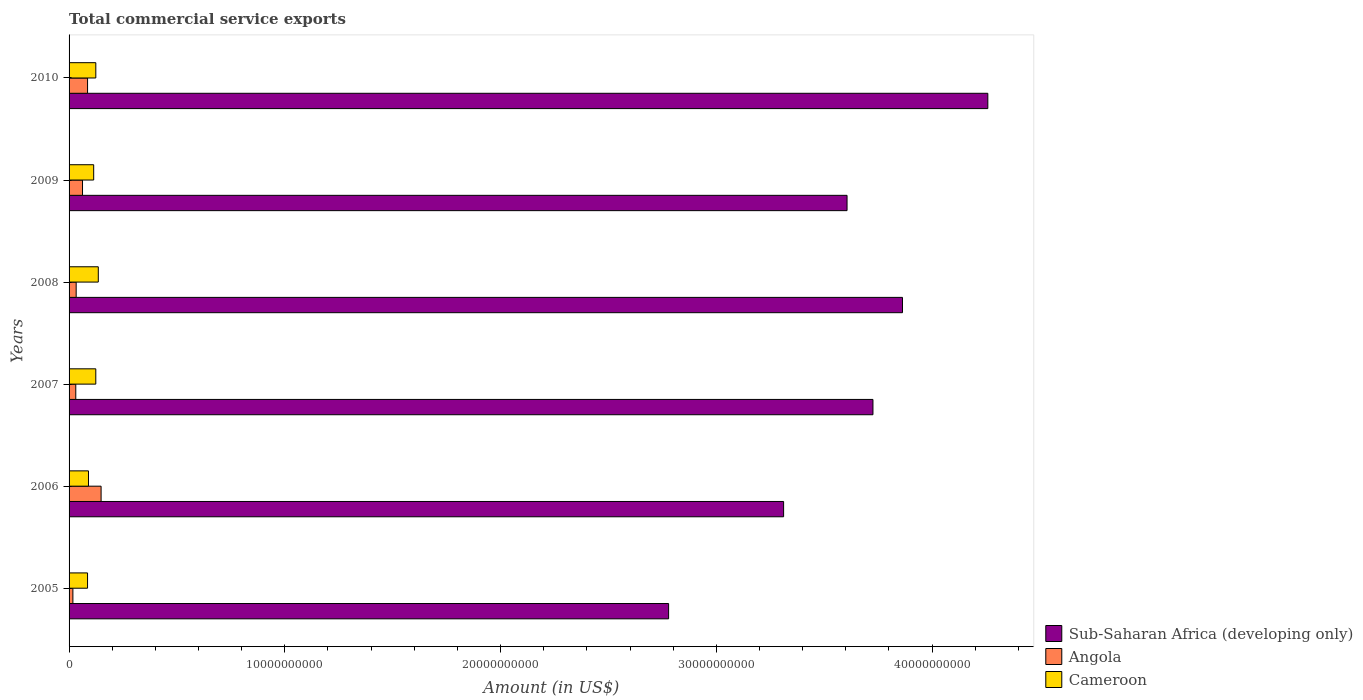Are the number of bars on each tick of the Y-axis equal?
Make the answer very short. Yes. How many bars are there on the 5th tick from the top?
Offer a terse response. 3. In how many cases, is the number of bars for a given year not equal to the number of legend labels?
Give a very brief answer. 0. What is the total commercial service exports in Sub-Saharan Africa (developing only) in 2009?
Your answer should be very brief. 3.61e+1. Across all years, what is the maximum total commercial service exports in Cameroon?
Keep it short and to the point. 1.35e+09. Across all years, what is the minimum total commercial service exports in Sub-Saharan Africa (developing only)?
Keep it short and to the point. 2.78e+1. In which year was the total commercial service exports in Sub-Saharan Africa (developing only) minimum?
Provide a succinct answer. 2005. What is the total total commercial service exports in Sub-Saharan Africa (developing only) in the graph?
Keep it short and to the point. 2.15e+11. What is the difference between the total commercial service exports in Cameroon in 2005 and that in 2008?
Ensure brevity in your answer.  -4.98e+08. What is the difference between the total commercial service exports in Angola in 2005 and the total commercial service exports in Sub-Saharan Africa (developing only) in 2009?
Offer a very short reply. -3.59e+1. What is the average total commercial service exports in Cameroon per year?
Make the answer very short. 1.12e+09. In the year 2009, what is the difference between the total commercial service exports in Angola and total commercial service exports in Cameroon?
Make the answer very short. -5.18e+08. In how many years, is the total commercial service exports in Angola greater than 32000000000 US$?
Provide a short and direct response. 0. What is the ratio of the total commercial service exports in Cameroon in 2006 to that in 2008?
Provide a succinct answer. 0.66. Is the total commercial service exports in Angola in 2006 less than that in 2010?
Make the answer very short. No. Is the difference between the total commercial service exports in Angola in 2008 and 2010 greater than the difference between the total commercial service exports in Cameroon in 2008 and 2010?
Provide a short and direct response. No. What is the difference between the highest and the second highest total commercial service exports in Angola?
Give a very brief answer. 6.27e+08. What is the difference between the highest and the lowest total commercial service exports in Angola?
Offer a very short reply. 1.31e+09. In how many years, is the total commercial service exports in Angola greater than the average total commercial service exports in Angola taken over all years?
Keep it short and to the point. 2. What does the 1st bar from the top in 2008 represents?
Provide a succinct answer. Cameroon. What does the 3rd bar from the bottom in 2009 represents?
Offer a very short reply. Cameroon. How many bars are there?
Give a very brief answer. 18. Are all the bars in the graph horizontal?
Offer a terse response. Yes. Are the values on the major ticks of X-axis written in scientific E-notation?
Provide a succinct answer. No. How many legend labels are there?
Offer a very short reply. 3. What is the title of the graph?
Provide a short and direct response. Total commercial service exports. Does "Greece" appear as one of the legend labels in the graph?
Ensure brevity in your answer.  No. What is the label or title of the X-axis?
Provide a succinct answer. Amount (in US$). What is the Amount (in US$) in Sub-Saharan Africa (developing only) in 2005?
Your answer should be very brief. 2.78e+1. What is the Amount (in US$) of Angola in 2005?
Make the answer very short. 1.77e+08. What is the Amount (in US$) in Cameroon in 2005?
Your answer should be compact. 8.57e+08. What is the Amount (in US$) of Sub-Saharan Africa (developing only) in 2006?
Offer a very short reply. 3.31e+1. What is the Amount (in US$) in Angola in 2006?
Ensure brevity in your answer.  1.48e+09. What is the Amount (in US$) in Cameroon in 2006?
Keep it short and to the point. 9.00e+08. What is the Amount (in US$) in Sub-Saharan Africa (developing only) in 2007?
Offer a terse response. 3.73e+1. What is the Amount (in US$) in Angola in 2007?
Provide a short and direct response. 3.11e+08. What is the Amount (in US$) in Cameroon in 2007?
Your answer should be very brief. 1.24e+09. What is the Amount (in US$) of Sub-Saharan Africa (developing only) in 2008?
Your answer should be compact. 3.86e+1. What is the Amount (in US$) of Angola in 2008?
Make the answer very short. 3.29e+08. What is the Amount (in US$) of Cameroon in 2008?
Your answer should be very brief. 1.35e+09. What is the Amount (in US$) in Sub-Saharan Africa (developing only) in 2009?
Give a very brief answer. 3.61e+1. What is the Amount (in US$) of Angola in 2009?
Make the answer very short. 6.23e+08. What is the Amount (in US$) of Cameroon in 2009?
Keep it short and to the point. 1.14e+09. What is the Amount (in US$) of Sub-Saharan Africa (developing only) in 2010?
Give a very brief answer. 4.26e+1. What is the Amount (in US$) in Angola in 2010?
Provide a short and direct response. 8.57e+08. What is the Amount (in US$) in Cameroon in 2010?
Ensure brevity in your answer.  1.24e+09. Across all years, what is the maximum Amount (in US$) of Sub-Saharan Africa (developing only)?
Your answer should be compact. 4.26e+1. Across all years, what is the maximum Amount (in US$) of Angola?
Your answer should be compact. 1.48e+09. Across all years, what is the maximum Amount (in US$) of Cameroon?
Ensure brevity in your answer.  1.35e+09. Across all years, what is the minimum Amount (in US$) in Sub-Saharan Africa (developing only)?
Make the answer very short. 2.78e+1. Across all years, what is the minimum Amount (in US$) of Angola?
Your answer should be compact. 1.77e+08. Across all years, what is the minimum Amount (in US$) in Cameroon?
Provide a succinct answer. 8.57e+08. What is the total Amount (in US$) of Sub-Saharan Africa (developing only) in the graph?
Your answer should be very brief. 2.15e+11. What is the total Amount (in US$) in Angola in the graph?
Ensure brevity in your answer.  3.78e+09. What is the total Amount (in US$) in Cameroon in the graph?
Provide a succinct answer. 6.73e+09. What is the difference between the Amount (in US$) in Sub-Saharan Africa (developing only) in 2005 and that in 2006?
Provide a short and direct response. -5.33e+09. What is the difference between the Amount (in US$) in Angola in 2005 and that in 2006?
Make the answer very short. -1.31e+09. What is the difference between the Amount (in US$) in Cameroon in 2005 and that in 2006?
Your response must be concise. -4.33e+07. What is the difference between the Amount (in US$) of Sub-Saharan Africa (developing only) in 2005 and that in 2007?
Give a very brief answer. -9.47e+09. What is the difference between the Amount (in US$) of Angola in 2005 and that in 2007?
Make the answer very short. -1.34e+08. What is the difference between the Amount (in US$) in Cameroon in 2005 and that in 2007?
Offer a terse response. -3.82e+08. What is the difference between the Amount (in US$) of Sub-Saharan Africa (developing only) in 2005 and that in 2008?
Your response must be concise. -1.08e+1. What is the difference between the Amount (in US$) in Angola in 2005 and that in 2008?
Your answer should be compact. -1.53e+08. What is the difference between the Amount (in US$) in Cameroon in 2005 and that in 2008?
Your response must be concise. -4.98e+08. What is the difference between the Amount (in US$) of Sub-Saharan Africa (developing only) in 2005 and that in 2009?
Your answer should be compact. -8.27e+09. What is the difference between the Amount (in US$) in Angola in 2005 and that in 2009?
Provide a succinct answer. -4.46e+08. What is the difference between the Amount (in US$) in Cameroon in 2005 and that in 2009?
Offer a terse response. -2.85e+08. What is the difference between the Amount (in US$) in Sub-Saharan Africa (developing only) in 2005 and that in 2010?
Your answer should be compact. -1.48e+1. What is the difference between the Amount (in US$) of Angola in 2005 and that in 2010?
Make the answer very short. -6.80e+08. What is the difference between the Amount (in US$) in Cameroon in 2005 and that in 2010?
Give a very brief answer. -3.83e+08. What is the difference between the Amount (in US$) in Sub-Saharan Africa (developing only) in 2006 and that in 2007?
Make the answer very short. -4.14e+09. What is the difference between the Amount (in US$) of Angola in 2006 and that in 2007?
Keep it short and to the point. 1.17e+09. What is the difference between the Amount (in US$) of Cameroon in 2006 and that in 2007?
Provide a short and direct response. -3.39e+08. What is the difference between the Amount (in US$) of Sub-Saharan Africa (developing only) in 2006 and that in 2008?
Your answer should be very brief. -5.51e+09. What is the difference between the Amount (in US$) of Angola in 2006 and that in 2008?
Give a very brief answer. 1.15e+09. What is the difference between the Amount (in US$) in Cameroon in 2006 and that in 2008?
Offer a terse response. -4.55e+08. What is the difference between the Amount (in US$) in Sub-Saharan Africa (developing only) in 2006 and that in 2009?
Your answer should be compact. -2.94e+09. What is the difference between the Amount (in US$) of Angola in 2006 and that in 2009?
Ensure brevity in your answer.  8.61e+08. What is the difference between the Amount (in US$) of Cameroon in 2006 and that in 2009?
Ensure brevity in your answer.  -2.41e+08. What is the difference between the Amount (in US$) of Sub-Saharan Africa (developing only) in 2006 and that in 2010?
Your answer should be very brief. -9.47e+09. What is the difference between the Amount (in US$) in Angola in 2006 and that in 2010?
Your response must be concise. 6.27e+08. What is the difference between the Amount (in US$) in Cameroon in 2006 and that in 2010?
Your answer should be compact. -3.40e+08. What is the difference between the Amount (in US$) in Sub-Saharan Africa (developing only) in 2007 and that in 2008?
Your response must be concise. -1.37e+09. What is the difference between the Amount (in US$) of Angola in 2007 and that in 2008?
Your answer should be very brief. -1.87e+07. What is the difference between the Amount (in US$) in Cameroon in 2007 and that in 2008?
Ensure brevity in your answer.  -1.16e+08. What is the difference between the Amount (in US$) in Sub-Saharan Africa (developing only) in 2007 and that in 2009?
Give a very brief answer. 1.20e+09. What is the difference between the Amount (in US$) in Angola in 2007 and that in 2009?
Ensure brevity in your answer.  -3.12e+08. What is the difference between the Amount (in US$) of Cameroon in 2007 and that in 2009?
Ensure brevity in your answer.  9.78e+07. What is the difference between the Amount (in US$) in Sub-Saharan Africa (developing only) in 2007 and that in 2010?
Provide a short and direct response. -5.32e+09. What is the difference between the Amount (in US$) in Angola in 2007 and that in 2010?
Keep it short and to the point. -5.46e+08. What is the difference between the Amount (in US$) in Cameroon in 2007 and that in 2010?
Ensure brevity in your answer.  -8.30e+05. What is the difference between the Amount (in US$) in Sub-Saharan Africa (developing only) in 2008 and that in 2009?
Your response must be concise. 2.57e+09. What is the difference between the Amount (in US$) of Angola in 2008 and that in 2009?
Your answer should be very brief. -2.94e+08. What is the difference between the Amount (in US$) of Cameroon in 2008 and that in 2009?
Give a very brief answer. 2.13e+08. What is the difference between the Amount (in US$) of Sub-Saharan Africa (developing only) in 2008 and that in 2010?
Make the answer very short. -3.96e+09. What is the difference between the Amount (in US$) of Angola in 2008 and that in 2010?
Keep it short and to the point. -5.27e+08. What is the difference between the Amount (in US$) of Cameroon in 2008 and that in 2010?
Offer a terse response. 1.15e+08. What is the difference between the Amount (in US$) in Sub-Saharan Africa (developing only) in 2009 and that in 2010?
Give a very brief answer. -6.53e+09. What is the difference between the Amount (in US$) in Angola in 2009 and that in 2010?
Make the answer very short. -2.34e+08. What is the difference between the Amount (in US$) of Cameroon in 2009 and that in 2010?
Your answer should be very brief. -9.86e+07. What is the difference between the Amount (in US$) of Sub-Saharan Africa (developing only) in 2005 and the Amount (in US$) of Angola in 2006?
Offer a terse response. 2.63e+1. What is the difference between the Amount (in US$) of Sub-Saharan Africa (developing only) in 2005 and the Amount (in US$) of Cameroon in 2006?
Make the answer very short. 2.69e+1. What is the difference between the Amount (in US$) of Angola in 2005 and the Amount (in US$) of Cameroon in 2006?
Give a very brief answer. -7.23e+08. What is the difference between the Amount (in US$) of Sub-Saharan Africa (developing only) in 2005 and the Amount (in US$) of Angola in 2007?
Keep it short and to the point. 2.75e+1. What is the difference between the Amount (in US$) in Sub-Saharan Africa (developing only) in 2005 and the Amount (in US$) in Cameroon in 2007?
Offer a terse response. 2.66e+1. What is the difference between the Amount (in US$) of Angola in 2005 and the Amount (in US$) of Cameroon in 2007?
Provide a short and direct response. -1.06e+09. What is the difference between the Amount (in US$) in Sub-Saharan Africa (developing only) in 2005 and the Amount (in US$) in Angola in 2008?
Your answer should be compact. 2.75e+1. What is the difference between the Amount (in US$) in Sub-Saharan Africa (developing only) in 2005 and the Amount (in US$) in Cameroon in 2008?
Make the answer very short. 2.64e+1. What is the difference between the Amount (in US$) in Angola in 2005 and the Amount (in US$) in Cameroon in 2008?
Provide a succinct answer. -1.18e+09. What is the difference between the Amount (in US$) of Sub-Saharan Africa (developing only) in 2005 and the Amount (in US$) of Angola in 2009?
Provide a succinct answer. 2.72e+1. What is the difference between the Amount (in US$) in Sub-Saharan Africa (developing only) in 2005 and the Amount (in US$) in Cameroon in 2009?
Offer a very short reply. 2.66e+1. What is the difference between the Amount (in US$) of Angola in 2005 and the Amount (in US$) of Cameroon in 2009?
Offer a terse response. -9.64e+08. What is the difference between the Amount (in US$) in Sub-Saharan Africa (developing only) in 2005 and the Amount (in US$) in Angola in 2010?
Make the answer very short. 2.69e+1. What is the difference between the Amount (in US$) of Sub-Saharan Africa (developing only) in 2005 and the Amount (in US$) of Cameroon in 2010?
Your response must be concise. 2.65e+1. What is the difference between the Amount (in US$) of Angola in 2005 and the Amount (in US$) of Cameroon in 2010?
Keep it short and to the point. -1.06e+09. What is the difference between the Amount (in US$) in Sub-Saharan Africa (developing only) in 2006 and the Amount (in US$) in Angola in 2007?
Your answer should be very brief. 3.28e+1. What is the difference between the Amount (in US$) in Sub-Saharan Africa (developing only) in 2006 and the Amount (in US$) in Cameroon in 2007?
Offer a terse response. 3.19e+1. What is the difference between the Amount (in US$) of Angola in 2006 and the Amount (in US$) of Cameroon in 2007?
Offer a terse response. 2.45e+08. What is the difference between the Amount (in US$) of Sub-Saharan Africa (developing only) in 2006 and the Amount (in US$) of Angola in 2008?
Offer a terse response. 3.28e+1. What is the difference between the Amount (in US$) in Sub-Saharan Africa (developing only) in 2006 and the Amount (in US$) in Cameroon in 2008?
Give a very brief answer. 3.18e+1. What is the difference between the Amount (in US$) in Angola in 2006 and the Amount (in US$) in Cameroon in 2008?
Your answer should be compact. 1.30e+08. What is the difference between the Amount (in US$) of Sub-Saharan Africa (developing only) in 2006 and the Amount (in US$) of Angola in 2009?
Keep it short and to the point. 3.25e+1. What is the difference between the Amount (in US$) in Sub-Saharan Africa (developing only) in 2006 and the Amount (in US$) in Cameroon in 2009?
Your answer should be compact. 3.20e+1. What is the difference between the Amount (in US$) of Angola in 2006 and the Amount (in US$) of Cameroon in 2009?
Your answer should be compact. 3.43e+08. What is the difference between the Amount (in US$) of Sub-Saharan Africa (developing only) in 2006 and the Amount (in US$) of Angola in 2010?
Your answer should be compact. 3.23e+1. What is the difference between the Amount (in US$) in Sub-Saharan Africa (developing only) in 2006 and the Amount (in US$) in Cameroon in 2010?
Your answer should be very brief. 3.19e+1. What is the difference between the Amount (in US$) of Angola in 2006 and the Amount (in US$) of Cameroon in 2010?
Your answer should be compact. 2.44e+08. What is the difference between the Amount (in US$) in Sub-Saharan Africa (developing only) in 2007 and the Amount (in US$) in Angola in 2008?
Provide a succinct answer. 3.69e+1. What is the difference between the Amount (in US$) of Sub-Saharan Africa (developing only) in 2007 and the Amount (in US$) of Cameroon in 2008?
Offer a very short reply. 3.59e+1. What is the difference between the Amount (in US$) of Angola in 2007 and the Amount (in US$) of Cameroon in 2008?
Your answer should be very brief. -1.04e+09. What is the difference between the Amount (in US$) of Sub-Saharan Africa (developing only) in 2007 and the Amount (in US$) of Angola in 2009?
Offer a terse response. 3.66e+1. What is the difference between the Amount (in US$) of Sub-Saharan Africa (developing only) in 2007 and the Amount (in US$) of Cameroon in 2009?
Give a very brief answer. 3.61e+1. What is the difference between the Amount (in US$) of Angola in 2007 and the Amount (in US$) of Cameroon in 2009?
Provide a short and direct response. -8.31e+08. What is the difference between the Amount (in US$) of Sub-Saharan Africa (developing only) in 2007 and the Amount (in US$) of Angola in 2010?
Make the answer very short. 3.64e+1. What is the difference between the Amount (in US$) in Sub-Saharan Africa (developing only) in 2007 and the Amount (in US$) in Cameroon in 2010?
Provide a short and direct response. 3.60e+1. What is the difference between the Amount (in US$) in Angola in 2007 and the Amount (in US$) in Cameroon in 2010?
Your response must be concise. -9.29e+08. What is the difference between the Amount (in US$) in Sub-Saharan Africa (developing only) in 2008 and the Amount (in US$) in Angola in 2009?
Provide a succinct answer. 3.80e+1. What is the difference between the Amount (in US$) in Sub-Saharan Africa (developing only) in 2008 and the Amount (in US$) in Cameroon in 2009?
Provide a short and direct response. 3.75e+1. What is the difference between the Amount (in US$) in Angola in 2008 and the Amount (in US$) in Cameroon in 2009?
Your answer should be compact. -8.12e+08. What is the difference between the Amount (in US$) of Sub-Saharan Africa (developing only) in 2008 and the Amount (in US$) of Angola in 2010?
Your response must be concise. 3.78e+1. What is the difference between the Amount (in US$) in Sub-Saharan Africa (developing only) in 2008 and the Amount (in US$) in Cameroon in 2010?
Ensure brevity in your answer.  3.74e+1. What is the difference between the Amount (in US$) in Angola in 2008 and the Amount (in US$) in Cameroon in 2010?
Provide a succinct answer. -9.10e+08. What is the difference between the Amount (in US$) in Sub-Saharan Africa (developing only) in 2009 and the Amount (in US$) in Angola in 2010?
Your response must be concise. 3.52e+1. What is the difference between the Amount (in US$) of Sub-Saharan Africa (developing only) in 2009 and the Amount (in US$) of Cameroon in 2010?
Your answer should be very brief. 3.48e+1. What is the difference between the Amount (in US$) of Angola in 2009 and the Amount (in US$) of Cameroon in 2010?
Your answer should be compact. -6.17e+08. What is the average Amount (in US$) in Sub-Saharan Africa (developing only) per year?
Your response must be concise. 3.59e+1. What is the average Amount (in US$) of Angola per year?
Provide a short and direct response. 6.30e+08. What is the average Amount (in US$) in Cameroon per year?
Offer a terse response. 1.12e+09. In the year 2005, what is the difference between the Amount (in US$) of Sub-Saharan Africa (developing only) and Amount (in US$) of Angola?
Your answer should be very brief. 2.76e+1. In the year 2005, what is the difference between the Amount (in US$) in Sub-Saharan Africa (developing only) and Amount (in US$) in Cameroon?
Give a very brief answer. 2.69e+1. In the year 2005, what is the difference between the Amount (in US$) in Angola and Amount (in US$) in Cameroon?
Your answer should be compact. -6.80e+08. In the year 2006, what is the difference between the Amount (in US$) in Sub-Saharan Africa (developing only) and Amount (in US$) in Angola?
Offer a very short reply. 3.16e+1. In the year 2006, what is the difference between the Amount (in US$) of Sub-Saharan Africa (developing only) and Amount (in US$) of Cameroon?
Give a very brief answer. 3.22e+1. In the year 2006, what is the difference between the Amount (in US$) of Angola and Amount (in US$) of Cameroon?
Provide a succinct answer. 5.84e+08. In the year 2007, what is the difference between the Amount (in US$) of Sub-Saharan Africa (developing only) and Amount (in US$) of Angola?
Give a very brief answer. 3.70e+1. In the year 2007, what is the difference between the Amount (in US$) in Sub-Saharan Africa (developing only) and Amount (in US$) in Cameroon?
Keep it short and to the point. 3.60e+1. In the year 2007, what is the difference between the Amount (in US$) of Angola and Amount (in US$) of Cameroon?
Your answer should be very brief. -9.28e+08. In the year 2008, what is the difference between the Amount (in US$) in Sub-Saharan Africa (developing only) and Amount (in US$) in Angola?
Give a very brief answer. 3.83e+1. In the year 2008, what is the difference between the Amount (in US$) in Sub-Saharan Africa (developing only) and Amount (in US$) in Cameroon?
Ensure brevity in your answer.  3.73e+1. In the year 2008, what is the difference between the Amount (in US$) of Angola and Amount (in US$) of Cameroon?
Make the answer very short. -1.03e+09. In the year 2009, what is the difference between the Amount (in US$) in Sub-Saharan Africa (developing only) and Amount (in US$) in Angola?
Offer a terse response. 3.54e+1. In the year 2009, what is the difference between the Amount (in US$) of Sub-Saharan Africa (developing only) and Amount (in US$) of Cameroon?
Ensure brevity in your answer.  3.49e+1. In the year 2009, what is the difference between the Amount (in US$) of Angola and Amount (in US$) of Cameroon?
Your response must be concise. -5.18e+08. In the year 2010, what is the difference between the Amount (in US$) of Sub-Saharan Africa (developing only) and Amount (in US$) of Angola?
Make the answer very short. 4.17e+1. In the year 2010, what is the difference between the Amount (in US$) of Sub-Saharan Africa (developing only) and Amount (in US$) of Cameroon?
Keep it short and to the point. 4.13e+1. In the year 2010, what is the difference between the Amount (in US$) in Angola and Amount (in US$) in Cameroon?
Keep it short and to the point. -3.83e+08. What is the ratio of the Amount (in US$) of Sub-Saharan Africa (developing only) in 2005 to that in 2006?
Your answer should be compact. 0.84. What is the ratio of the Amount (in US$) in Angola in 2005 to that in 2006?
Your answer should be compact. 0.12. What is the ratio of the Amount (in US$) of Cameroon in 2005 to that in 2006?
Ensure brevity in your answer.  0.95. What is the ratio of the Amount (in US$) in Sub-Saharan Africa (developing only) in 2005 to that in 2007?
Provide a short and direct response. 0.75. What is the ratio of the Amount (in US$) in Angola in 2005 to that in 2007?
Keep it short and to the point. 0.57. What is the ratio of the Amount (in US$) of Cameroon in 2005 to that in 2007?
Give a very brief answer. 0.69. What is the ratio of the Amount (in US$) in Sub-Saharan Africa (developing only) in 2005 to that in 2008?
Keep it short and to the point. 0.72. What is the ratio of the Amount (in US$) in Angola in 2005 to that in 2008?
Your answer should be compact. 0.54. What is the ratio of the Amount (in US$) of Cameroon in 2005 to that in 2008?
Offer a terse response. 0.63. What is the ratio of the Amount (in US$) of Sub-Saharan Africa (developing only) in 2005 to that in 2009?
Ensure brevity in your answer.  0.77. What is the ratio of the Amount (in US$) in Angola in 2005 to that in 2009?
Your response must be concise. 0.28. What is the ratio of the Amount (in US$) in Cameroon in 2005 to that in 2009?
Your answer should be compact. 0.75. What is the ratio of the Amount (in US$) of Sub-Saharan Africa (developing only) in 2005 to that in 2010?
Offer a terse response. 0.65. What is the ratio of the Amount (in US$) in Angola in 2005 to that in 2010?
Provide a succinct answer. 0.21. What is the ratio of the Amount (in US$) in Cameroon in 2005 to that in 2010?
Your answer should be compact. 0.69. What is the ratio of the Amount (in US$) in Sub-Saharan Africa (developing only) in 2006 to that in 2007?
Give a very brief answer. 0.89. What is the ratio of the Amount (in US$) of Angola in 2006 to that in 2007?
Offer a very short reply. 4.78. What is the ratio of the Amount (in US$) in Cameroon in 2006 to that in 2007?
Provide a succinct answer. 0.73. What is the ratio of the Amount (in US$) of Sub-Saharan Africa (developing only) in 2006 to that in 2008?
Your answer should be very brief. 0.86. What is the ratio of the Amount (in US$) of Angola in 2006 to that in 2008?
Offer a very short reply. 4.51. What is the ratio of the Amount (in US$) of Cameroon in 2006 to that in 2008?
Your answer should be very brief. 0.66. What is the ratio of the Amount (in US$) in Sub-Saharan Africa (developing only) in 2006 to that in 2009?
Your answer should be compact. 0.92. What is the ratio of the Amount (in US$) in Angola in 2006 to that in 2009?
Make the answer very short. 2.38. What is the ratio of the Amount (in US$) of Cameroon in 2006 to that in 2009?
Provide a succinct answer. 0.79. What is the ratio of the Amount (in US$) in Sub-Saharan Africa (developing only) in 2006 to that in 2010?
Provide a short and direct response. 0.78. What is the ratio of the Amount (in US$) in Angola in 2006 to that in 2010?
Your response must be concise. 1.73. What is the ratio of the Amount (in US$) in Cameroon in 2006 to that in 2010?
Your answer should be very brief. 0.73. What is the ratio of the Amount (in US$) of Sub-Saharan Africa (developing only) in 2007 to that in 2008?
Ensure brevity in your answer.  0.96. What is the ratio of the Amount (in US$) of Angola in 2007 to that in 2008?
Provide a succinct answer. 0.94. What is the ratio of the Amount (in US$) in Cameroon in 2007 to that in 2008?
Provide a short and direct response. 0.91. What is the ratio of the Amount (in US$) in Sub-Saharan Africa (developing only) in 2007 to that in 2009?
Your answer should be very brief. 1.03. What is the ratio of the Amount (in US$) in Angola in 2007 to that in 2009?
Keep it short and to the point. 0.5. What is the ratio of the Amount (in US$) in Cameroon in 2007 to that in 2009?
Offer a terse response. 1.09. What is the ratio of the Amount (in US$) of Angola in 2007 to that in 2010?
Make the answer very short. 0.36. What is the ratio of the Amount (in US$) in Cameroon in 2007 to that in 2010?
Offer a very short reply. 1. What is the ratio of the Amount (in US$) in Sub-Saharan Africa (developing only) in 2008 to that in 2009?
Keep it short and to the point. 1.07. What is the ratio of the Amount (in US$) of Angola in 2008 to that in 2009?
Your answer should be very brief. 0.53. What is the ratio of the Amount (in US$) in Cameroon in 2008 to that in 2009?
Ensure brevity in your answer.  1.19. What is the ratio of the Amount (in US$) in Sub-Saharan Africa (developing only) in 2008 to that in 2010?
Offer a terse response. 0.91. What is the ratio of the Amount (in US$) in Angola in 2008 to that in 2010?
Provide a short and direct response. 0.38. What is the ratio of the Amount (in US$) of Cameroon in 2008 to that in 2010?
Keep it short and to the point. 1.09. What is the ratio of the Amount (in US$) of Sub-Saharan Africa (developing only) in 2009 to that in 2010?
Give a very brief answer. 0.85. What is the ratio of the Amount (in US$) of Angola in 2009 to that in 2010?
Ensure brevity in your answer.  0.73. What is the ratio of the Amount (in US$) of Cameroon in 2009 to that in 2010?
Ensure brevity in your answer.  0.92. What is the difference between the highest and the second highest Amount (in US$) of Sub-Saharan Africa (developing only)?
Provide a short and direct response. 3.96e+09. What is the difference between the highest and the second highest Amount (in US$) in Angola?
Keep it short and to the point. 6.27e+08. What is the difference between the highest and the second highest Amount (in US$) of Cameroon?
Make the answer very short. 1.15e+08. What is the difference between the highest and the lowest Amount (in US$) of Sub-Saharan Africa (developing only)?
Make the answer very short. 1.48e+1. What is the difference between the highest and the lowest Amount (in US$) in Angola?
Give a very brief answer. 1.31e+09. What is the difference between the highest and the lowest Amount (in US$) of Cameroon?
Offer a very short reply. 4.98e+08. 